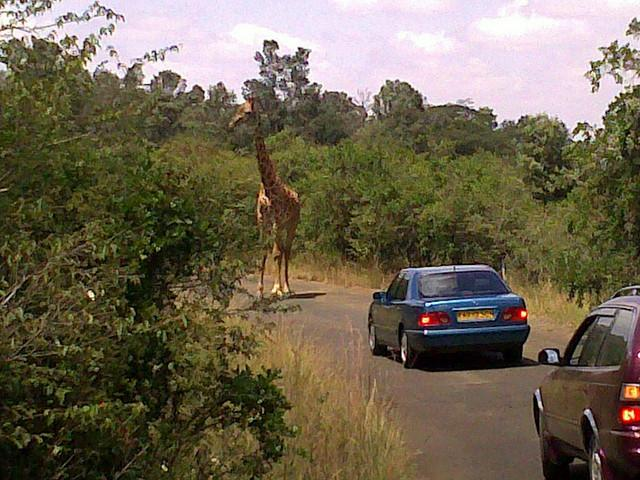What are you supposed to do when you meet an animal like this on the road?

Choices:
A) stop
B) reverse
C) go
D) hoot stop 